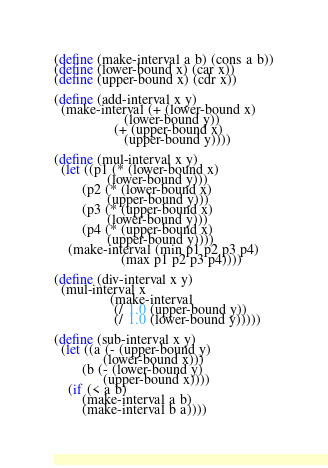<code> <loc_0><loc_0><loc_500><loc_500><_Scheme_>(define (make-interval a b) (cons a b))
(define (lower-bound x) (car x))
(define (upper-bound x) (cdr x))

(define (add-interval x y)
  (make-interval (+ (lower-bound x)
                    (lower-bound y))
                 (+ (upper-bound x)
                    (upper-bound y))))

(define (mul-interval x y)
  (let ((p1 (* (lower-bound x)
               (lower-bound y)))
        (p2 (* (lower-bound x)
               (upper-bound y)))
        (p3 (* (upper-bound x)
               (lower-bound y)))
        (p4 (* (upper-bound x)
               (upper-bound y))))
    (make-interval (min p1 p2 p3 p4)
                   (max p1 p2 p3 p4))))

(define (div-interval x y)
  (mul-interval x
                (make-interval
                 (/ 1.0 (upper-bound y))
                 (/ 1.0 (lower-bound y)))))

(define (sub-interval x y)
  (let ((a (- (upper-bound y)
              (lower-bound x)))
        (b (- (lower-bound y)
              (upper-bound x))))
    (if (< a b)
        (make-interval a b)
        (make-interval b a))))
</code> 